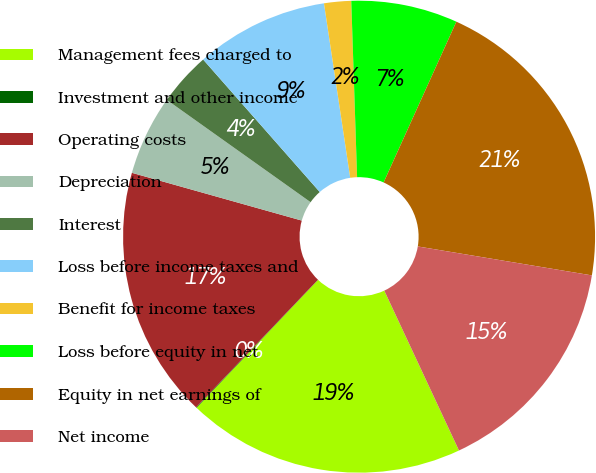Convert chart to OTSL. <chart><loc_0><loc_0><loc_500><loc_500><pie_chart><fcel>Management fees charged to<fcel>Investment and other income<fcel>Operating costs<fcel>Depreciation<fcel>Interest<fcel>Loss before income taxes and<fcel>Benefit for income taxes<fcel>Loss before equity in net<fcel>Equity in net earnings of<fcel>Net income<nl><fcel>19.05%<fcel>0.04%<fcel>17.23%<fcel>5.48%<fcel>3.67%<fcel>9.11%<fcel>1.85%<fcel>7.29%<fcel>20.86%<fcel>15.42%<nl></chart> 